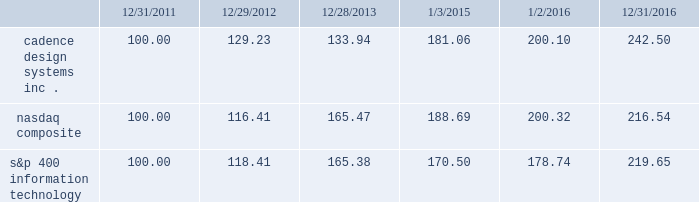Stockholder return performance graph the following graph compares the cumulative 5-year total stockholder return on our common stock relative to the cumulative total return of the nasdaq composite index and the s&p 400 information technology index .
The graph assumes that the value of the investment in our common stock and in each index on december 31 , 2011 ( including reinvestment of dividends ) was $ 100 and tracks it each year thereafter on the last day of our fiscal year through december 31 , 2016 and , for each index , on the last day of the calendar year .
Comparison of 5 year cumulative total return* among cadence design systems , inc. , the nasdaq composite index , and s&p 400 information technology cadence design systems , inc .
Nasdaq composite s&p 400 information technology 12/31/1612/28/13 1/2/1612/31/11 1/3/1512/29/12 *$ 100 invested on 12/31/11 in stock or index , including reinvestment of dividends .
Indexes calculated on month-end basis .
Copyright a9 2017 standard & poor 2019s , a division of s&p global .
All rights reserved. .
The stock price performance included in this graph is not necessarily indicative of future stock price performance. .
What is the rate of return of an investment in cadence design systems from the end of the year in 2015 to the end of the year in 2016? 
Computations: ((200.10 - 181.06) / 181.06)
Answer: 0.10516. 